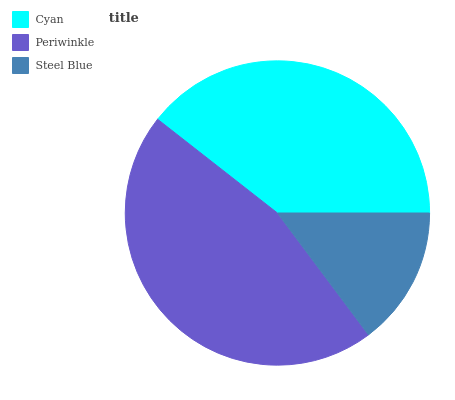Is Steel Blue the minimum?
Answer yes or no. Yes. Is Periwinkle the maximum?
Answer yes or no. Yes. Is Periwinkle the minimum?
Answer yes or no. No. Is Steel Blue the maximum?
Answer yes or no. No. Is Periwinkle greater than Steel Blue?
Answer yes or no. Yes. Is Steel Blue less than Periwinkle?
Answer yes or no. Yes. Is Steel Blue greater than Periwinkle?
Answer yes or no. No. Is Periwinkle less than Steel Blue?
Answer yes or no. No. Is Cyan the high median?
Answer yes or no. Yes. Is Cyan the low median?
Answer yes or no. Yes. Is Steel Blue the high median?
Answer yes or no. No. Is Periwinkle the low median?
Answer yes or no. No. 